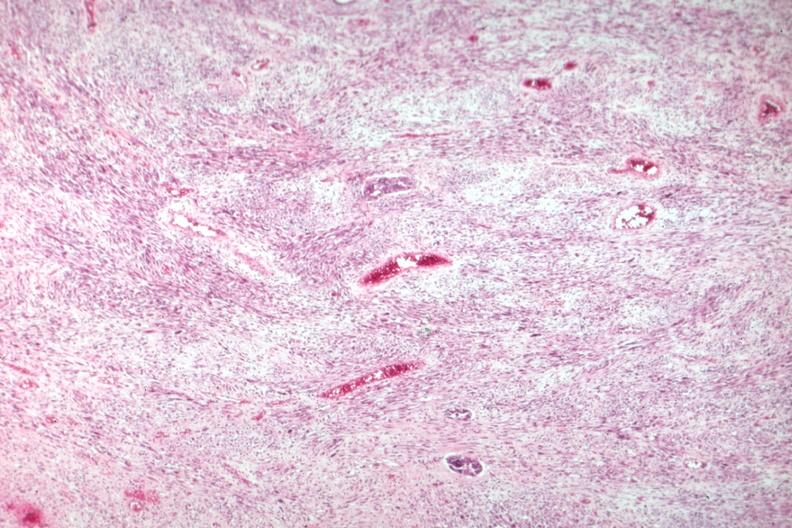does peritoneal fluid show nice view of tumor primarily stromal element?
Answer the question using a single word or phrase. No 